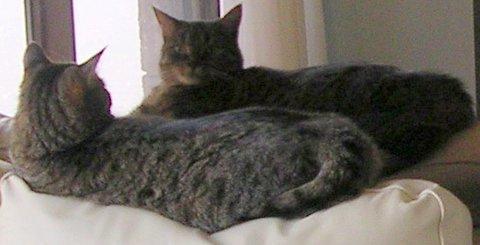How many cats are visible?
Give a very brief answer. 2. How many people is snowboarding?
Give a very brief answer. 0. 